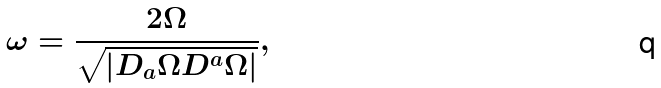Convert formula to latex. <formula><loc_0><loc_0><loc_500><loc_500>\omega = \frac { 2 \Omega } { \sqrt { | D _ { a } \Omega D ^ { a } \Omega | } } ,</formula> 